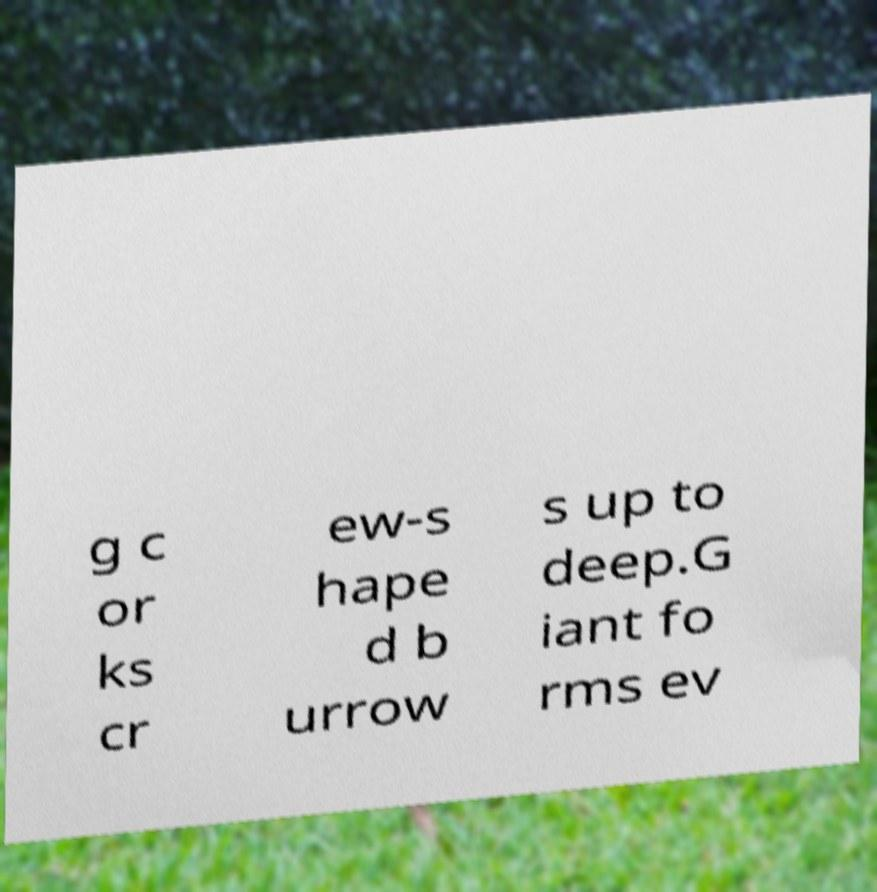Can you read and provide the text displayed in the image?This photo seems to have some interesting text. Can you extract and type it out for me? g c or ks cr ew-s hape d b urrow s up to deep.G iant fo rms ev 